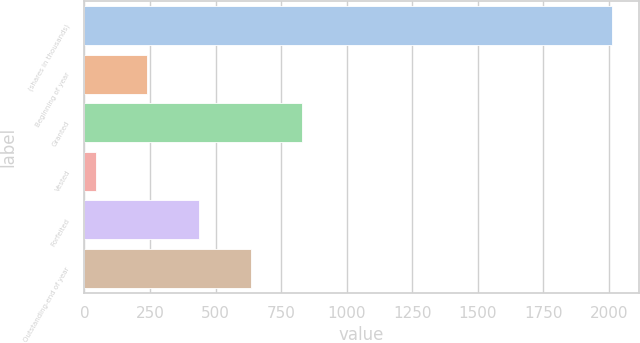<chart> <loc_0><loc_0><loc_500><loc_500><bar_chart><fcel>(shares in thousands)<fcel>Beginning of year<fcel>Granted<fcel>Vested<fcel>Forfeited<fcel>Outstanding-end of year<nl><fcel>2012<fcel>239.74<fcel>830.5<fcel>42.82<fcel>436.66<fcel>633.58<nl></chart> 